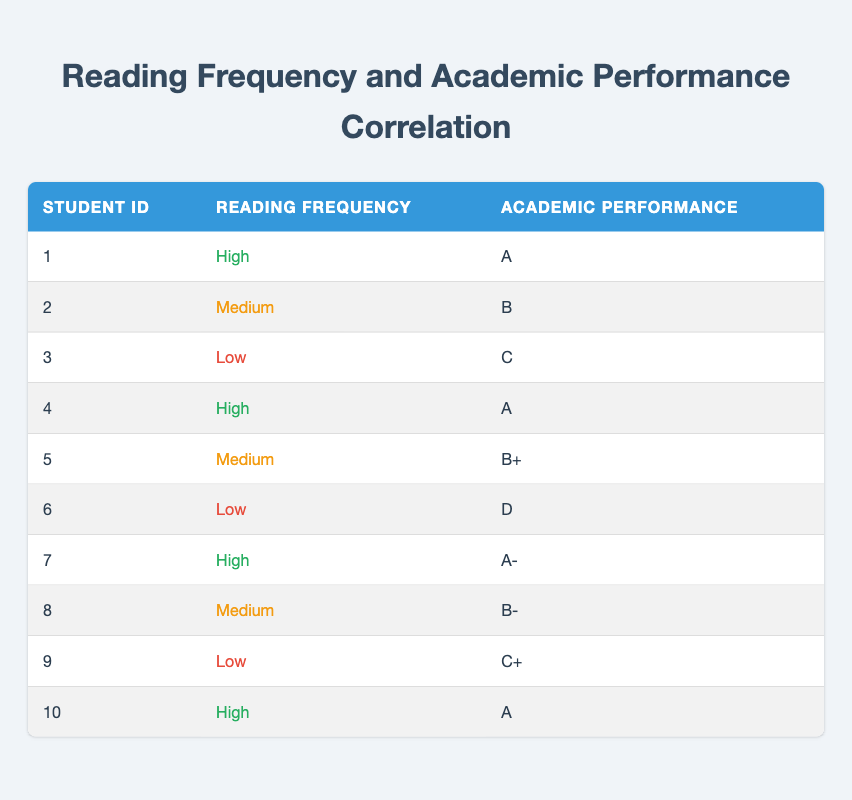How many students have a high reading frequency? There are four entries labeled "High" in the reading frequency column for student IDs 1, 4, 7, and 10.
Answer: 4 Which academic performance corresponds to a student with low reading frequency? Reviewing the rows where reading frequency is "Low", the academic performances are C (student 3), D (student 6), and C+ (student 9).
Answer: C, D, C+ What is the highest grade achieved among students with a medium reading frequency? The grades for medium reading frequency are B (student 2), B+ (student 5), and B- (student 8). The highest among these is B+.
Answer: B+ Are there any students who achieved an academic performance of D? Looking through the academic performance column, student 6 has a grade of D, confirming that there is at least one student with this grade.
Answer: Yes What is the average academic performance of students with high reading frequency? The grades for students with high reading frequency are A (student 1), A (student 4), A- (student 7), and A (student 10). To convert these to numerical values, A = 4.0, A- = 3.7. So, calculating the average: (4.0 + 4.0 + 3.7 + 4.0) / 4 = 3.925.
Answer: 3.925 How many students achieved an academic performance of A+ or higher? The table shows that grades labeled A or A- are the highest achieved. A, in this case, corresponds to three students (1, 4, and 10), while A- is one student (7). There are no A+ grades in the table.
Answer: 3 What is the relationship between reading frequency and academic performance based on this data? By analyzing the data, students with high reading frequencies generally achieve higher academic grades, as seen in the entries. Conversely, lower reading frequencies correspond to lower academic performances.
Answer: Positive correlation How many students show a consistent performance with their reading frequency? Students 1, 4, 7, and 10, all with high reading frequency, achieved grades of A or A- which indicates strong performance. In contrast, students with low reading frequency (3, 6, 9) exhibit lower grades (C, D, C+).
Answer: 7 